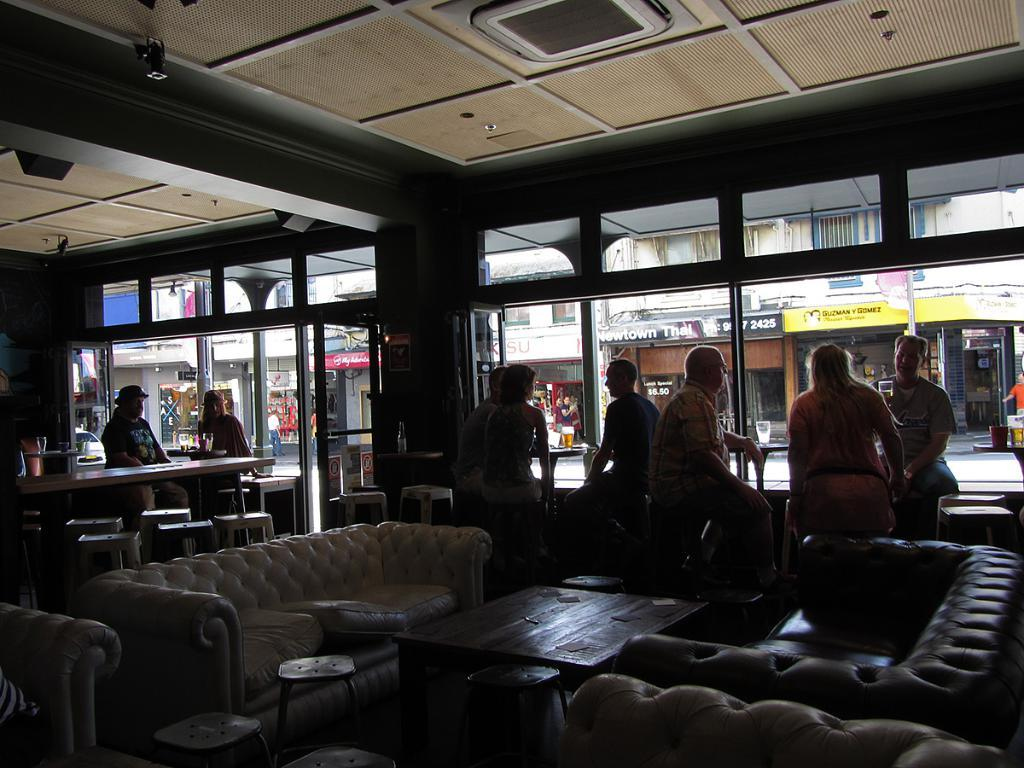Who or what can be seen in the image? There are people in the image. What type of furniture is present in the image? There is a sofa and chairs in the image. What other objects can be seen in the image? There is a table in the image. What can be seen in the background of the image? There are buildings in the image. What type of cord is being used to bite in the image? There is no cord or biting action present in the image. 